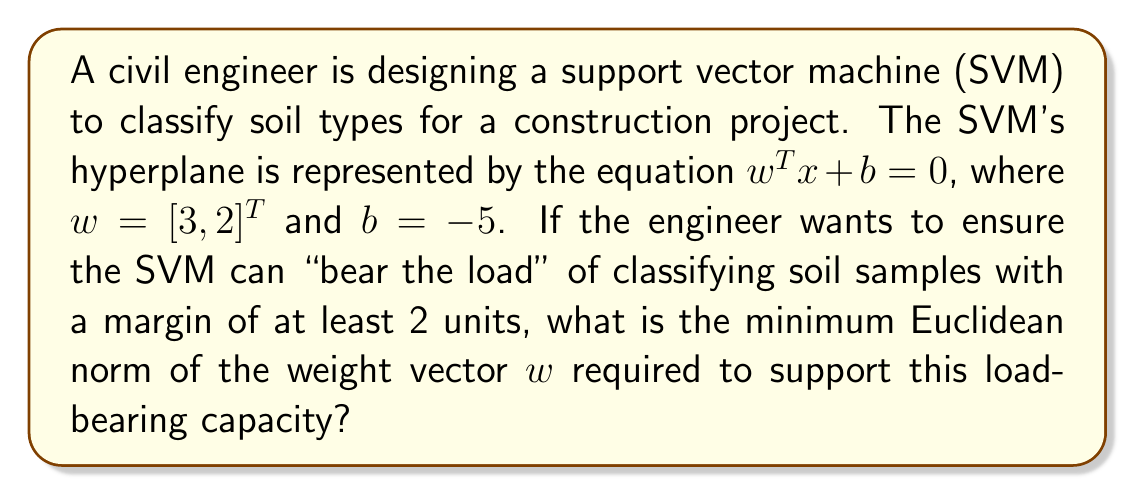Help me with this question. To solve this problem, we need to understand the relationship between the margin of an SVM and its weight vector. The margin of an SVM is defined as the distance between the hyperplane and the nearest data point. For a given weight vector $w$ and bias $b$, the margin is calculated as:

$$\text{margin} = \frac{1}{\|w\|}$$

where $\|w\|$ is the Euclidean norm of the weight vector.

Given:
1. The weight vector $w = [3, 2]^T$
2. The desired margin is at least 2 units

To find the minimum Euclidean norm of $w$ that supports a margin of 2 units:

1. Set up the equation:
   $$2 = \frac{1}{\|w\|}$$

2. Solve for $\|w\|$:
   $$\|w\| = \frac{1}{2}$$

3. Calculate the current Euclidean norm of $w$:
   $$\|w\| = \sqrt{3^2 + 2^2} = \sqrt{9 + 4} = \sqrt{13} \approx 3.61$$

4. Compare the current norm with the required norm:
   The current norm (3.61) is greater than the required norm (0.5), so we need to scale down the weight vector.

5. Calculate the scaling factor:
   $$\text{scaling factor} = \frac{0.5}{3.61} \approx 0.1386$$

6. Apply the scaling factor to the original weight vector:
   $$w_{\text{new}} = 0.1386 \cdot [3, 2]^T \approx [0.4158, 0.2772]^T$$

7. Verify the new weight vector's norm:
   $$\|w_{\text{new}}\| = \sqrt{0.4158^2 + 0.2772^2} \approx 0.5$$

Therefore, the minimum Euclidean norm of the weight vector $w$ required to support a margin of 2 units is 0.5.
Answer: The minimum Euclidean norm of the weight vector $w$ required to support a margin of 2 units is 0.5. 